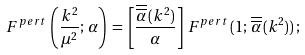Convert formula to latex. <formula><loc_0><loc_0><loc_500><loc_500>F ^ { p e r t } \, \left ( \frac { k ^ { 2 } } { \mu ^ { 2 } } ; \, \alpha \right ) \, = \, \left [ \frac { \overline { { { \overline { \alpha } } } } \, ( k ^ { 2 } ) } { \alpha } \right ] \, F ^ { p e r t } \, ( 1 ; \, \overline { { { \overline { \alpha } } } } \, ( k ^ { 2 } ) ) \, ;</formula> 